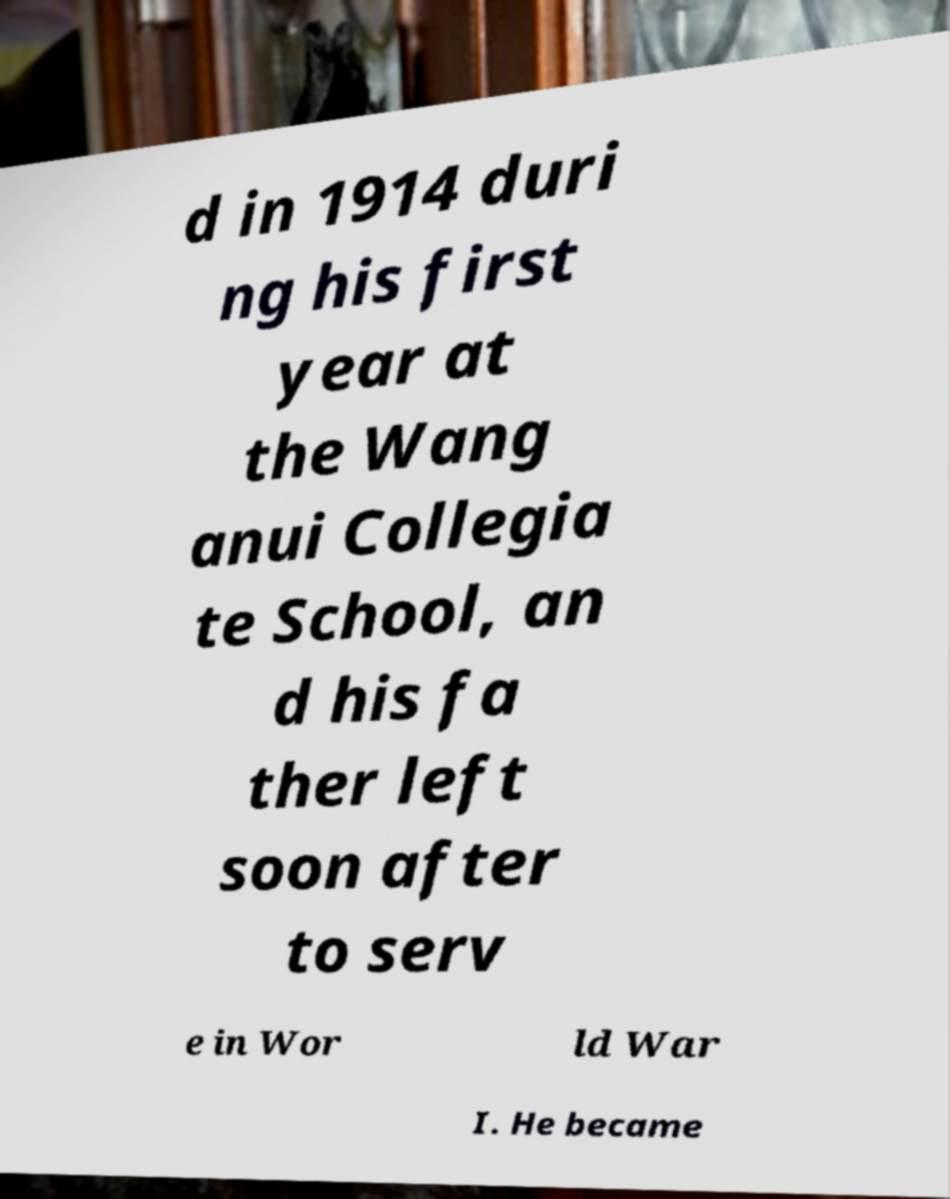There's text embedded in this image that I need extracted. Can you transcribe it verbatim? d in 1914 duri ng his first year at the Wang anui Collegia te School, an d his fa ther left soon after to serv e in Wor ld War I. He became 